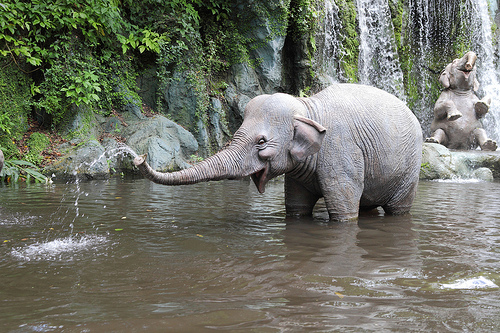Is there a surfboard or a can in the photograph?
Answer the question using a single word or phrase. No Is there a tennis ball or a fence in the image? No Are there either elephants or fences? Yes 